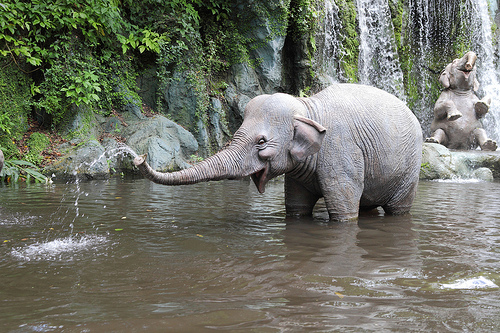Is there a surfboard or a can in the photograph?
Answer the question using a single word or phrase. No Is there a tennis ball or a fence in the image? No Are there either elephants or fences? Yes 